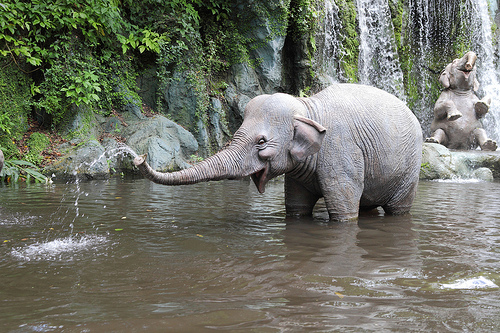Is there a surfboard or a can in the photograph?
Answer the question using a single word or phrase. No Is there a tennis ball or a fence in the image? No Are there either elephants or fences? Yes 